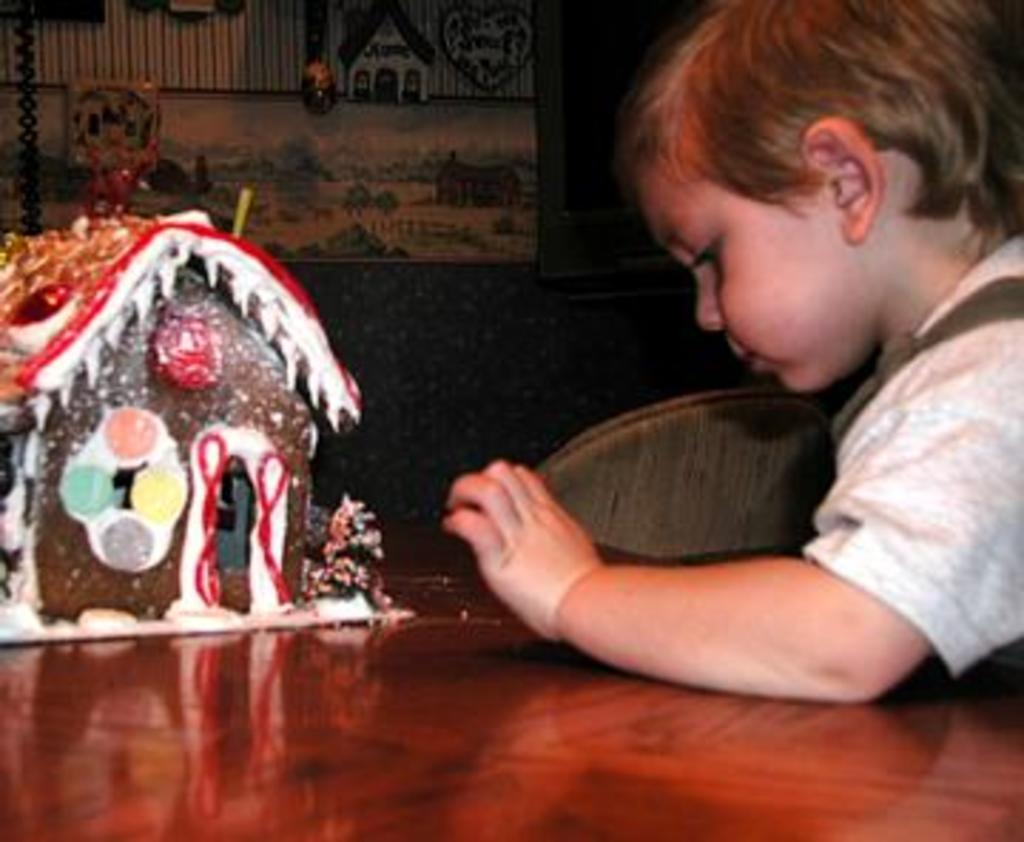What object is placed on the table in the image? There is a toy house on the table. Who is present in the image? There is a child in the image. What piece of furniture is located beside the child? There is a chair beside the child. What can be seen hanging on the wall in the image? There is a frame hanging on the wall. What type of society is depicted in the image? The image does not depict a society; it features a child, a toy house, a chair, and a frame on the wall. Can you compare the size of the toy house to the child in the image? The size of the toy house in relation to the child cannot be determined from the image. 